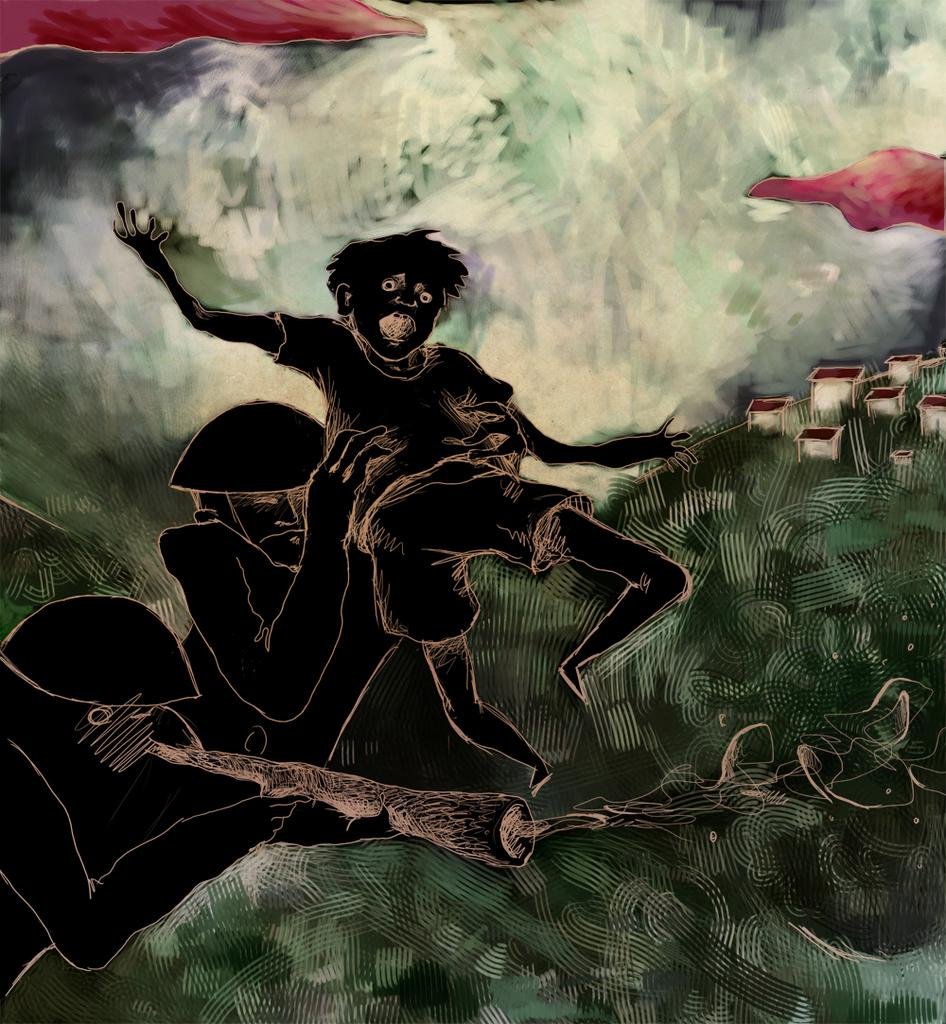What is the main subject of the image? The image is a picture of a painting. What color is the cloth in the painting? There is a cloth in red color at the top of the painting. What type of food is being prepared in the painting? There is no food visible in the painting; it only features a cloth in red color at the top. What decision is being made by the person in the painting? There is no person depicted in the painting, only a cloth in red color at the top. 